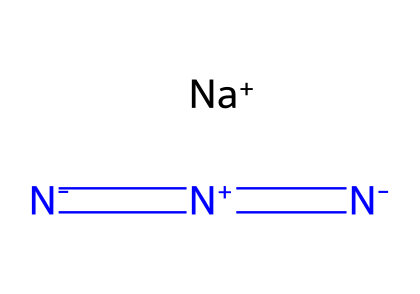What is the central atom in sodium azide? The central atom in sodium azide is nitrogen, as it connects the azide group and plays a key role in the structure.
Answer: nitrogen How many nitrogen atoms are present in sodium azide? By examining the SMILES representation, we can see there are three nitrogen atoms in sodium azide.
Answer: three What type of bond connects the nitrogen atoms in sodium azide? The nitrogen atoms are connected by double bonds, as indicated by the '=' signs in the SMILES notation.
Answer: double bonds What is the charge on the sodium ion in sodium azide? The sodium ion is represented as [Na+], indicating that it has a positive charge.
Answer: positive What is the overall charge of sodium azide? The overall charge is neutral; the positive charge of sodium balances the overall negative charge from the azide part.
Answer: neutral Why is sodium azide classified as an azide? Sodium azide is classified as an azide because it contains the azide ion, which is characterized by its three nitrogen atoms in a line (N3-) with the terminal nitrogens being negatively charged.
Answer: azide What functional group is present in the structure of sodium azide? The functional group present in sodium azide is the azide group (-N3), which is characteristic of azides as a class of compounds.
Answer: azide group 